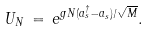Convert formula to latex. <formula><loc_0><loc_0><loc_500><loc_500>U _ { N } \, = \, e ^ { g N ( a _ { s } ^ { \dagger } - a _ { s } ) / \sqrt { M } } .</formula> 